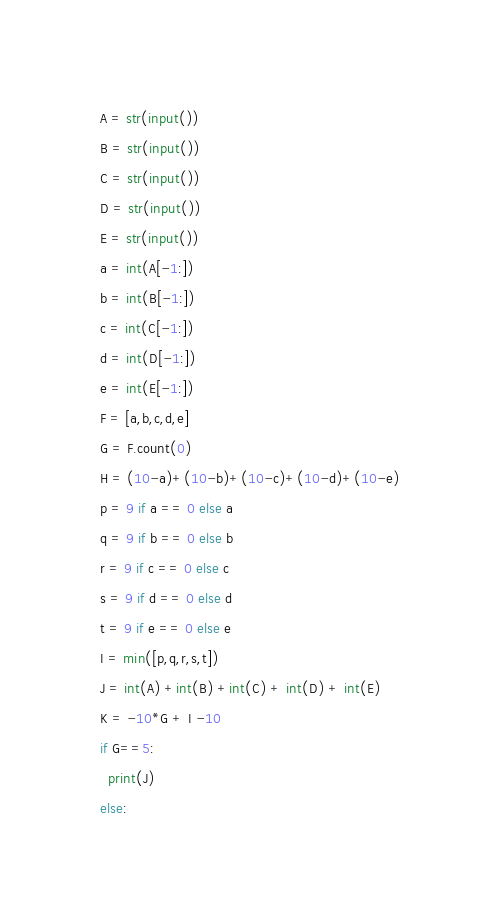Convert code to text. <code><loc_0><loc_0><loc_500><loc_500><_Python_>A = str(input())
B = str(input())
C = str(input())
D = str(input())
E = str(input())
a = int(A[-1:])
b = int(B[-1:])
c = int(C[-1:])
d = int(D[-1:])
e = int(E[-1:])
F = [a,b,c,d,e]
G = F.count(0)
H = (10-a)+(10-b)+(10-c)+(10-d)+(10-e)
p = 9 if a == 0 else a
q = 9 if b == 0 else b
r = 9 if c == 0 else c
s = 9 if d == 0 else d
t = 9 if e == 0 else e
I = min([p,q,r,s,t])
J = int(A) +int(B) +int(C) + int(D) + int(E)
K = -10*G + I -10
if G==5:
  print(J)
else:
</code> 